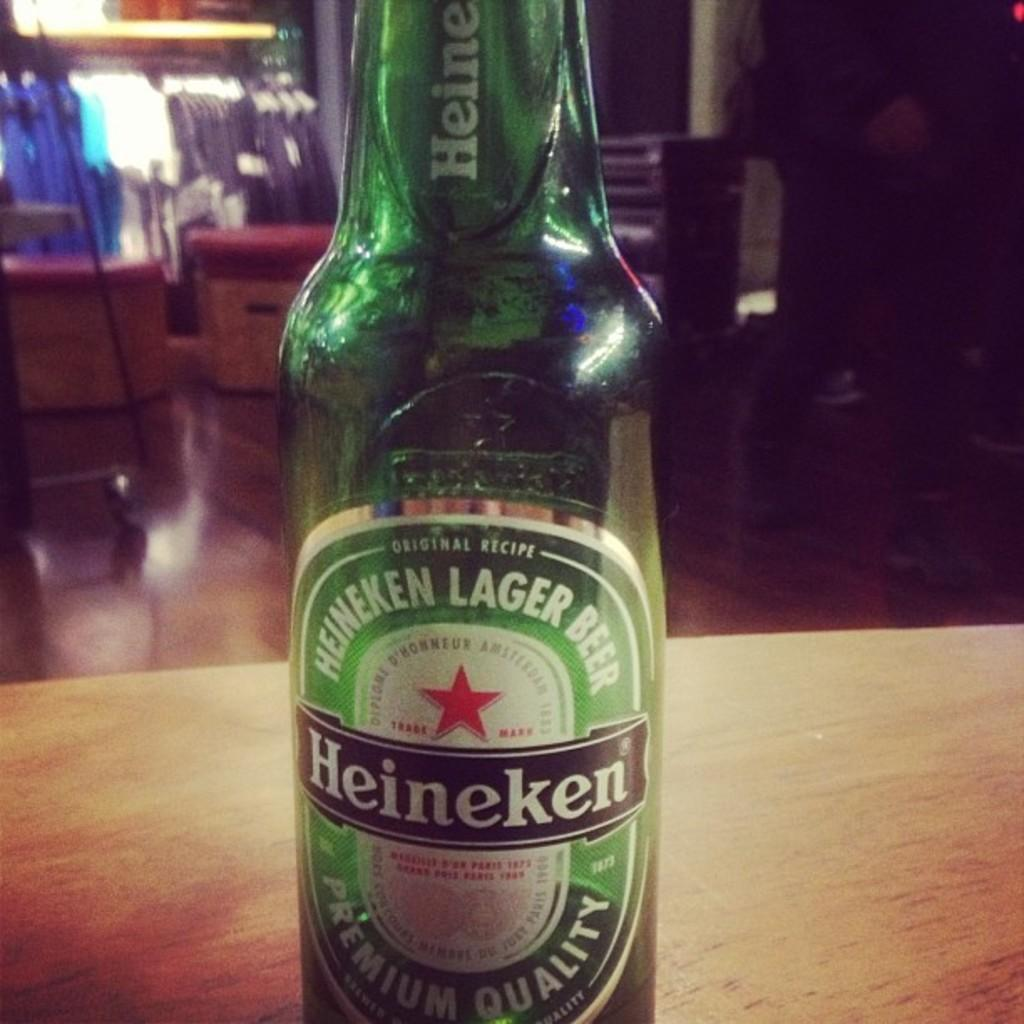<image>
Create a compact narrative representing the image presented. A green bottle of Heineken Lager Beer sits on a table. 